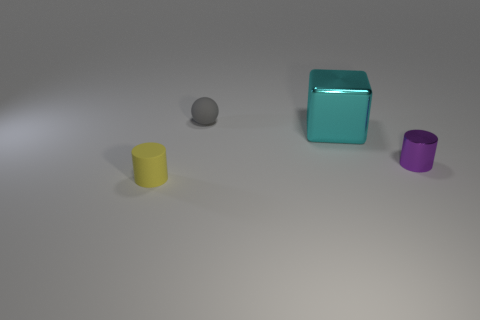Add 2 gray rubber spheres. How many objects exist? 6 Add 1 tiny gray balls. How many tiny gray balls are left? 2 Add 4 gray metallic spheres. How many gray metallic spheres exist? 4 Subtract 1 cyan cubes. How many objects are left? 3 Subtract all cubes. How many objects are left? 3 Subtract 1 cylinders. How many cylinders are left? 1 Subtract all brown cylinders. Subtract all green blocks. How many cylinders are left? 2 Subtract all gray spheres. How many yellow cylinders are left? 1 Subtract all brown cylinders. Subtract all tiny things. How many objects are left? 1 